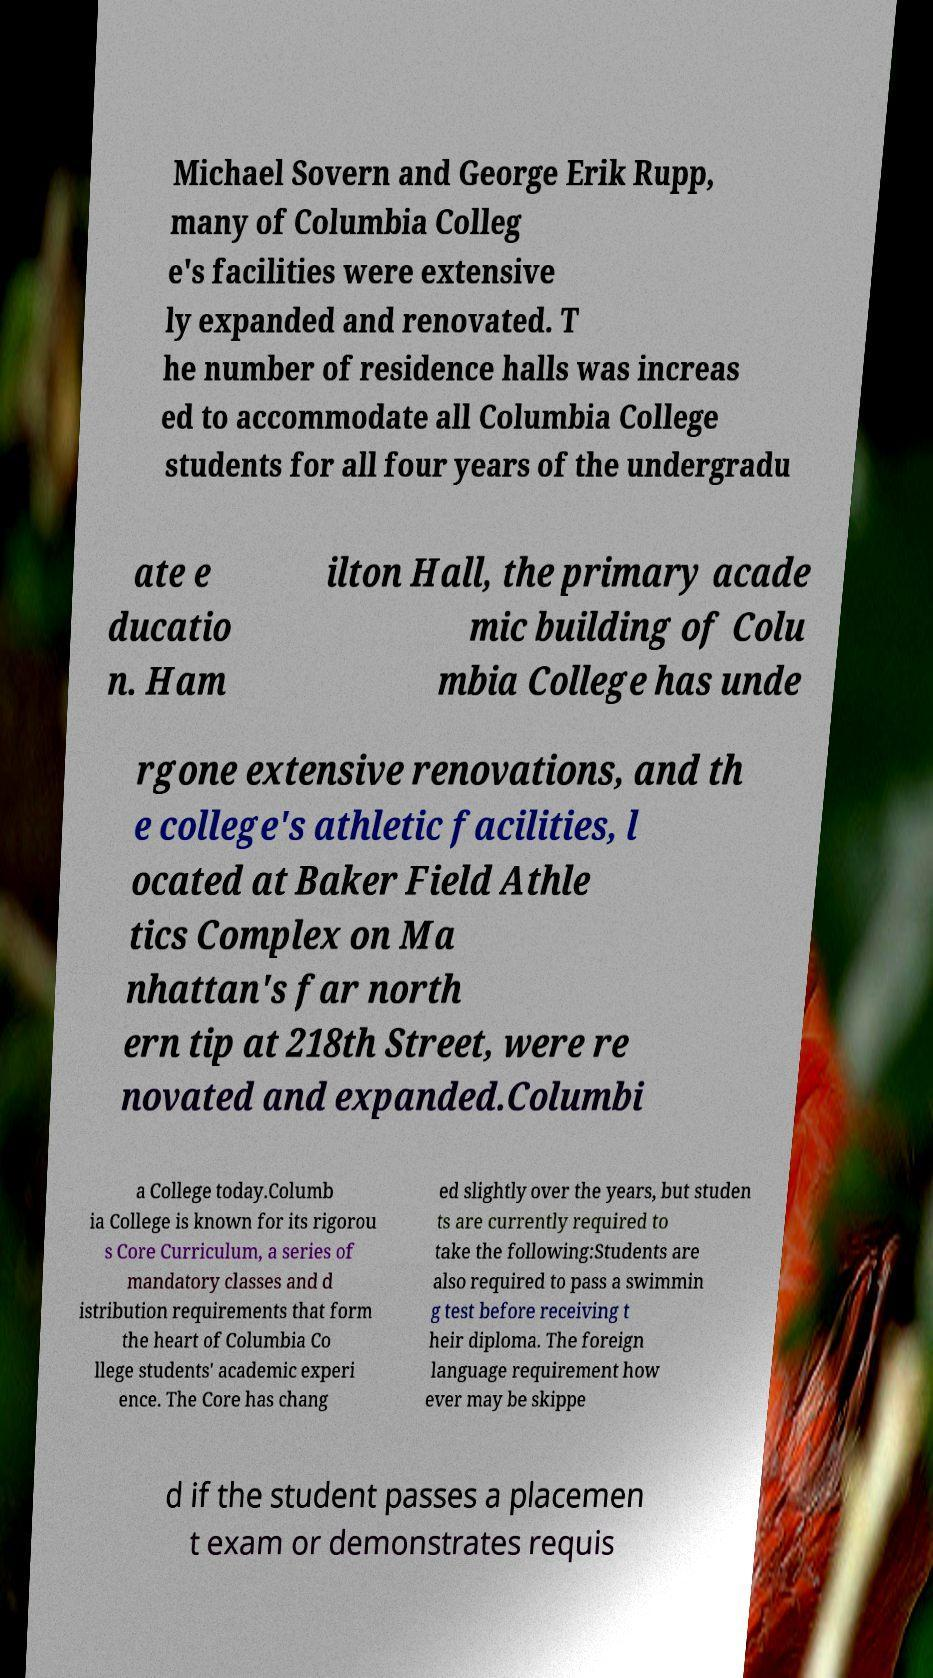Could you assist in decoding the text presented in this image and type it out clearly? Michael Sovern and George Erik Rupp, many of Columbia Colleg e's facilities were extensive ly expanded and renovated. T he number of residence halls was increas ed to accommodate all Columbia College students for all four years of the undergradu ate e ducatio n. Ham ilton Hall, the primary acade mic building of Colu mbia College has unde rgone extensive renovations, and th e college's athletic facilities, l ocated at Baker Field Athle tics Complex on Ma nhattan's far north ern tip at 218th Street, were re novated and expanded.Columbi a College today.Columb ia College is known for its rigorou s Core Curriculum, a series of mandatory classes and d istribution requirements that form the heart of Columbia Co llege students' academic experi ence. The Core has chang ed slightly over the years, but studen ts are currently required to take the following:Students are also required to pass a swimmin g test before receiving t heir diploma. The foreign language requirement how ever may be skippe d if the student passes a placemen t exam or demonstrates requis 